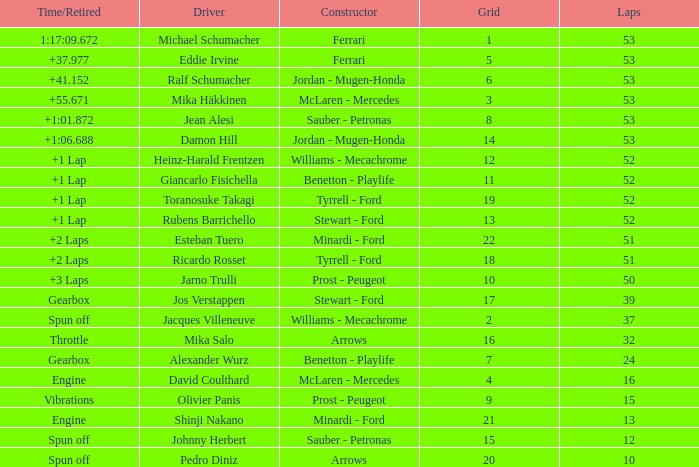What is the grid total for ralf schumacher racing over 53 laps? None. 